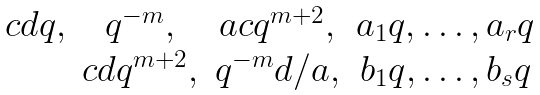Convert formula to latex. <formula><loc_0><loc_0><loc_500><loc_500>\begin{matrix} c d q , & q ^ { - m } , & a c q ^ { m + 2 } , & a _ { 1 } q , \dots , a _ { r } q \\ & c d q ^ { m + 2 } , & q ^ { - m } d / a , & b _ { 1 } q , \dots , b _ { s } q \end{matrix}</formula> 